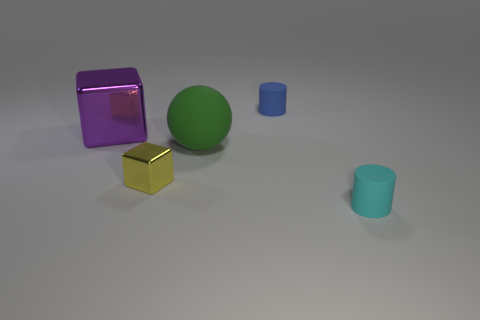Add 3 tiny blue metal things. How many objects exist? 8 Subtract all balls. How many objects are left? 4 Subtract all tiny cyan objects. Subtract all cyan objects. How many objects are left? 3 Add 4 matte objects. How many matte objects are left? 7 Add 5 cyan objects. How many cyan objects exist? 6 Subtract 0 gray cylinders. How many objects are left? 5 